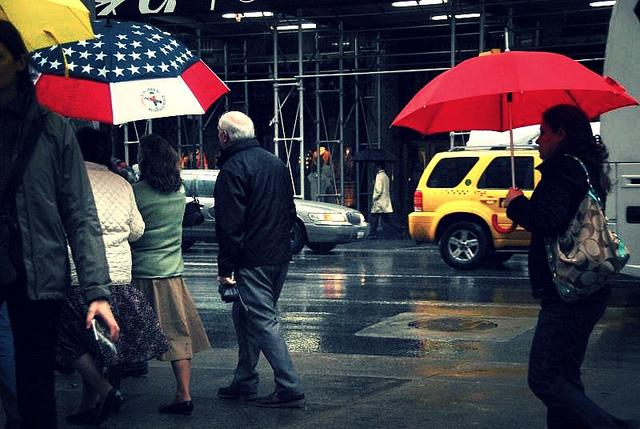One of the umbrellas is inspired by which country's flag? united states 